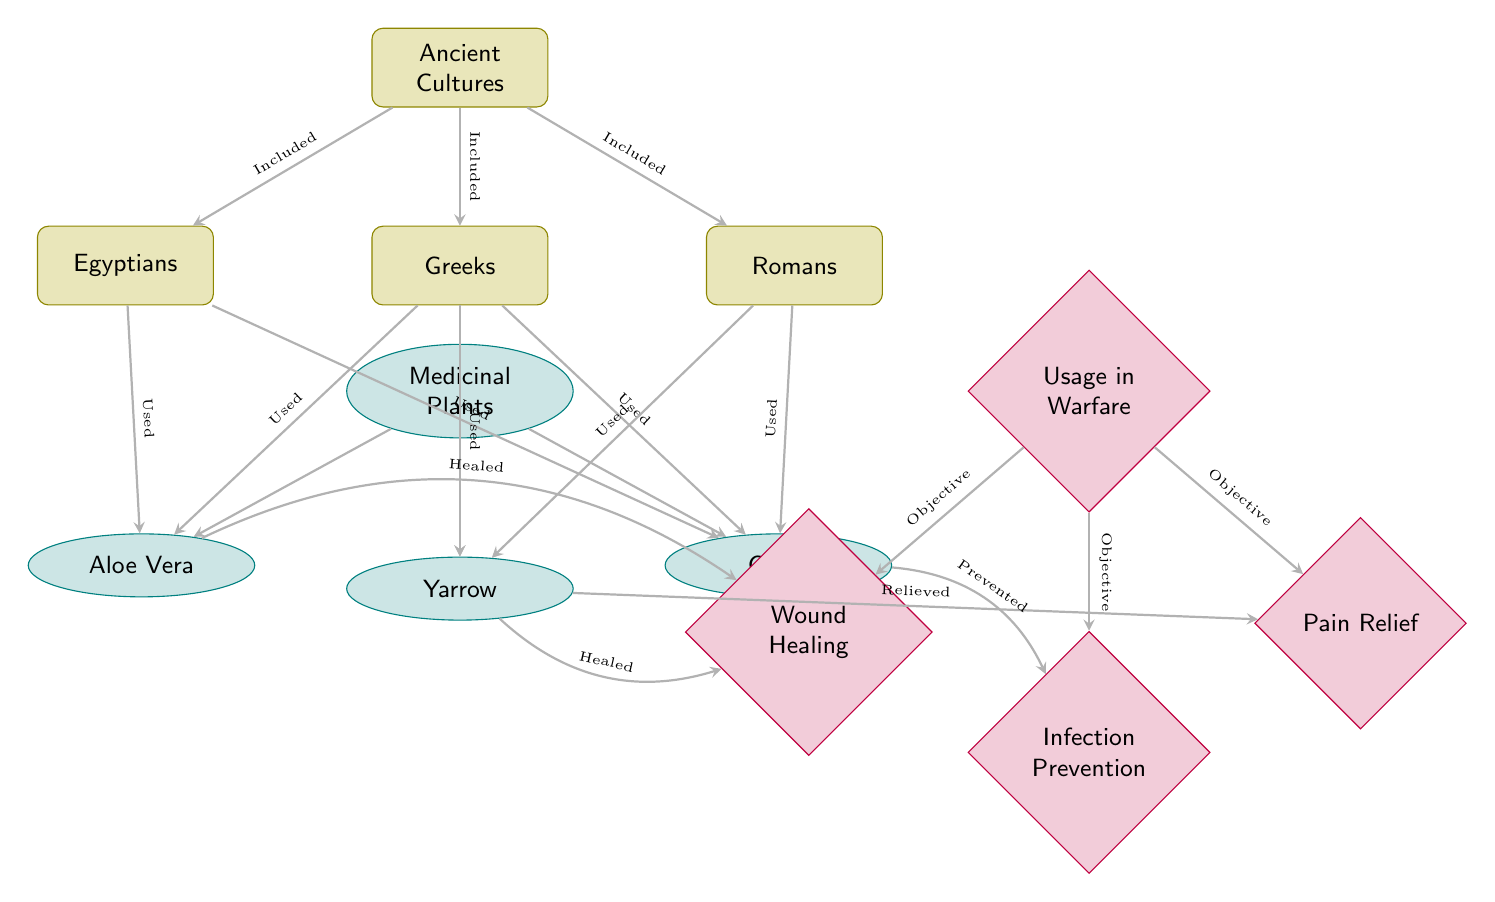What are the three ancient cultures depicted in the diagram? The diagram includes three cultures: Egyptians, Greeks, and Romans, represented as nodes under "Ancient Cultures."
Answer: Egyptians, Greeks, Romans Which medicinal plant is associated with infection prevention in this diagram? The diagram shows that Garlic is linked to "Infection Prevention," indicated by the directed edge from Garlic to that usage.
Answer: Garlic How many medicinal plants are represented in the diagram? The diagram includes three medicinal plants: Aloe Vera, Yarrow, and Garlic. These are represented as nodes directly connected to the "Medicinal Plants" node.
Answer: 3 What objective is Aloe Vera primarily associated with in warfare, according to the diagram? The diagram indicates that Aloe Vera is connected to "Wound Healing" with a directed edge labeled "Healed," showing its primary use in that context.
Answer: Wound Healing How many usage objectives are listed in the diagram? There are three usage objectives shown in the diagram: Wound Healing, Infection Prevention, and Pain Relief, each represented as distinct nodes under "Usage in Warfare."
Answer: 3 Which culture used Yarrow according to the diagram? The directed edge between the Greeks and Yarrow indicates that the Greeks are the culture associated with the use of Yarrow in the context of medicinal plants.
Answer: Greeks What relationship is shown between Yarrow and Pain Relief in the diagram? The diagram features a contraction from Yarrow to Pain Relief labeled "Relieved," indicating that Yarrow provides relief from pain.
Answer: Relieved Which medicinal plant is linked to more than one ancient culture as being used? The diagram illustrates that Garlic is linked to both Egyptians and Romans, indicated by directed edges from both cultures to the Garlic node.
Answer: Garlic What is the primary focus of the "Usage in Warfare" section of the diagram? The "Usage in Warfare" section focuses on three main objectives: Wound Healing, Infection Prevention, and Pain Relief, indicating the areas where medicinal plants were applied in warfare contexts.
Answer: Wound Healing, Infection Prevention, Pain Relief 